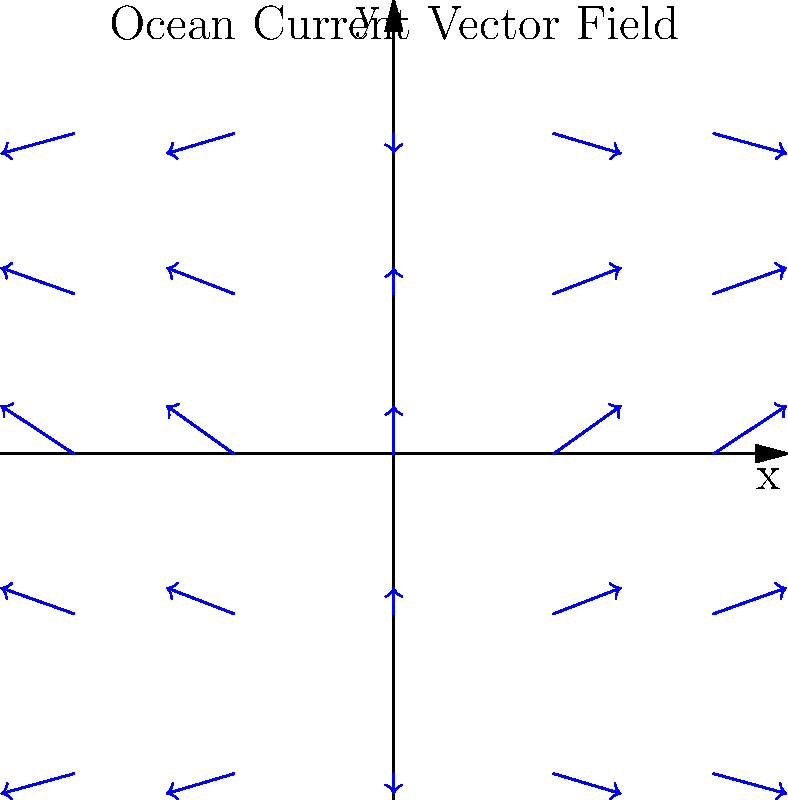In the vector field representation of ocean currents shown above, what mathematical functions best describe the x and y components of the current velocity? Assume the x-component is primarily sinusoidal and the y-component is primarily cosinusoidal. To determine the mathematical functions that best describe the x and y components of the current velocity, we need to analyze the vector field pattern:

1. Observe that the vectors form a circular pattern, suggesting trigonometric functions.

2. For the x-component:
   - The vectors show a sinusoidal pattern along the x-axis.
   - The amplitude appears to be about 0.5 units.
   - Therefore, the x-component can be described as $f(x) = 0.5 \sin(x)$.

3. For the y-component:
   - The vectors show a cosinusoidal pattern along the y-axis.
   - The amplitude appears to be about 0.3 units.
   - Therefore, the y-component can be described as $g(y) = 0.3 \cos(y)$.

4. Combining these observations, we can express the current velocity vector $\vec{v}$ as:

   $\vec{v} = \langle 0.5 \sin(x), 0.3 \cos(y) \rangle$

This vector field representation accurately captures the circular pattern and varying magnitudes of the ocean currents shown in the diagram.
Answer: $\vec{v} = \langle 0.5 \sin(x), 0.3 \cos(y) \rangle$ 